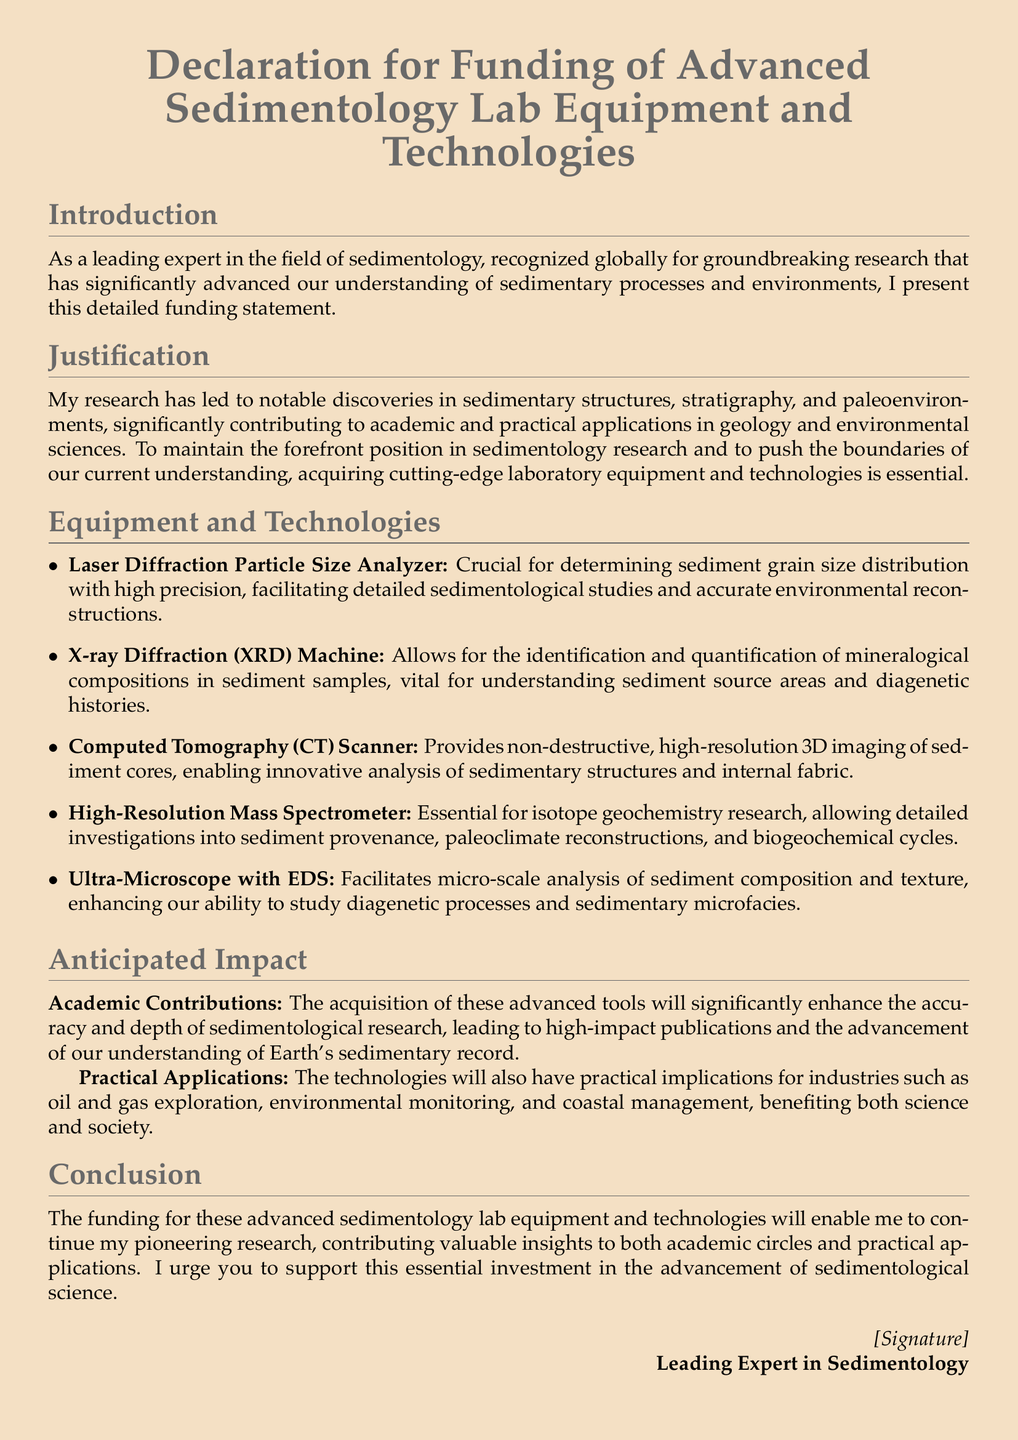What is the title of the document? The title of the document is presented at the beginning, stating its purpose.
Answer: Declaration for Funding of Advanced Sedimentology Lab Equipment and Technologies Who is the author of the document? The author is referred to in the conclusion as the leading expert in sedimentology.
Answer: Leading Expert in Sedimentology What is one type of equipment mentioned? The document lists several types of equipment, one of which can be identified.
Answer: Laser Diffraction Particle Size Analyzer What impact is anticipated from the funding? The document outlines expected contributions to academic research and practical applications.
Answer: Academic Contributions How many items are listed under Equipment and Technologies? The document explicitly provides a list of items under this section, which counts them.
Answer: Five What type of imaging does the CT Scanner provide? The document describes the CT Scanner's capability related to its imaging type.
Answer: High-resolution 3D imaging What is a key application of the High-Resolution Mass Spectrometer? The document highlights specific research areas where this equipment is critical.
Answer: Isotope geochemistry research What does the conclusion urge for? The conclusion makes a clear request related to the funding.
Answer: Support this essential investment What does the funding enable according to the conclusion? The conclusion states what the funding will allow the author to continue doing.
Answer: Pioneering research 